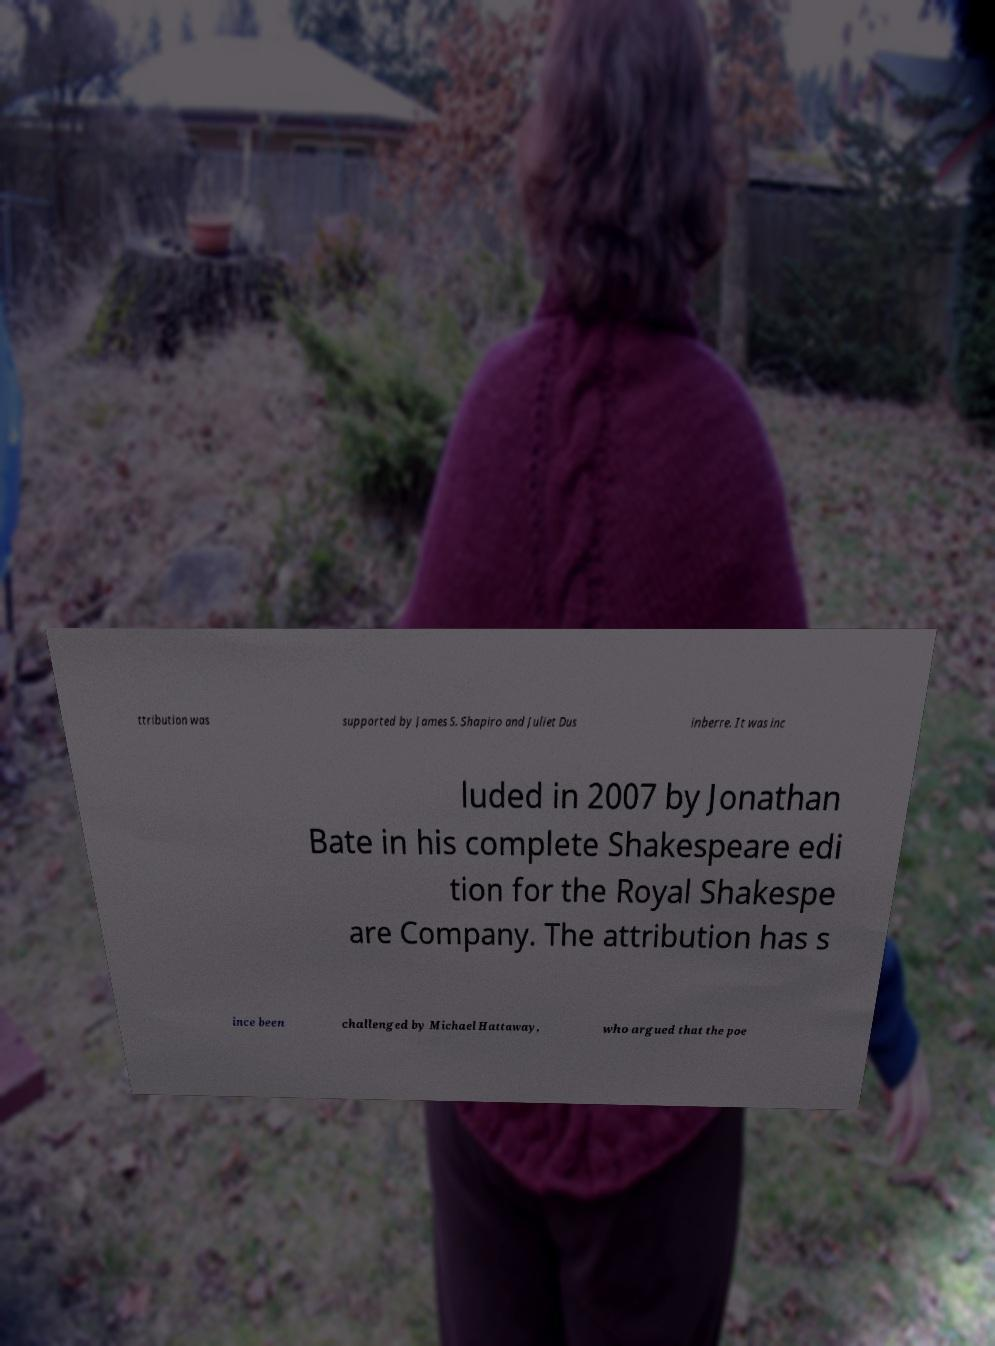Please read and relay the text visible in this image. What does it say? ttribution was supported by James S. Shapiro and Juliet Dus inberre. It was inc luded in 2007 by Jonathan Bate in his complete Shakespeare edi tion for the Royal Shakespe are Company. The attribution has s ince been challenged by Michael Hattaway, who argued that the poe 